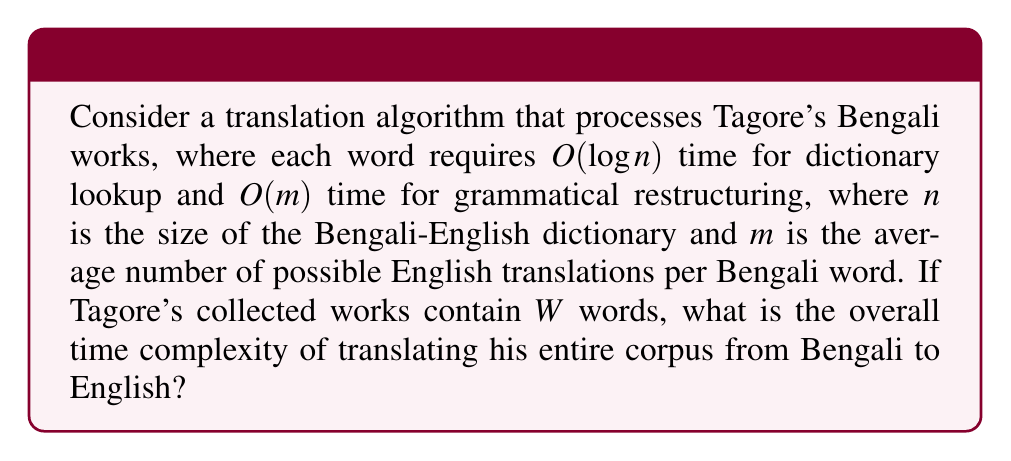Could you help me with this problem? Let's approach this step-by-step:

1) For each word in Tagore's works, we need to perform two operations:
   a) Dictionary lookup: $O(\log n)$
   b) Grammatical restructuring: $O(m)$

2) The total time for processing one word is therefore:
   $O(\log n + m)$

3) Since there are $W$ words in total, we multiply this by $W$:
   $O(W(\log n + m))$

4) Using the properties of Big O notation, we can simplify this to:
   $O(W\log n + Wm)$

5) Now, we need to consider which term dominates. This depends on the relative sizes of $\log n$ and $m$. However, in practical translation scenarios, $m$ (the number of possible translations per word) is often larger than $\log n$ (logarithm of dictionary size).

6) Therefore, we can reasonably assume that $Wm$ dominates $W\log n$ in most cases.

7) Thus, the overall time complexity can be simplified to:
   $O(Wm)$

This result suggests that the efficiency of the translation algorithm is primarily determined by the total number of words in Tagore's works and the average number of possible English translations per Bengali word.
Answer: $O(Wm)$, where $W$ is the total number of words in Tagore's works and $m$ is the average number of possible English translations per Bengali word. 